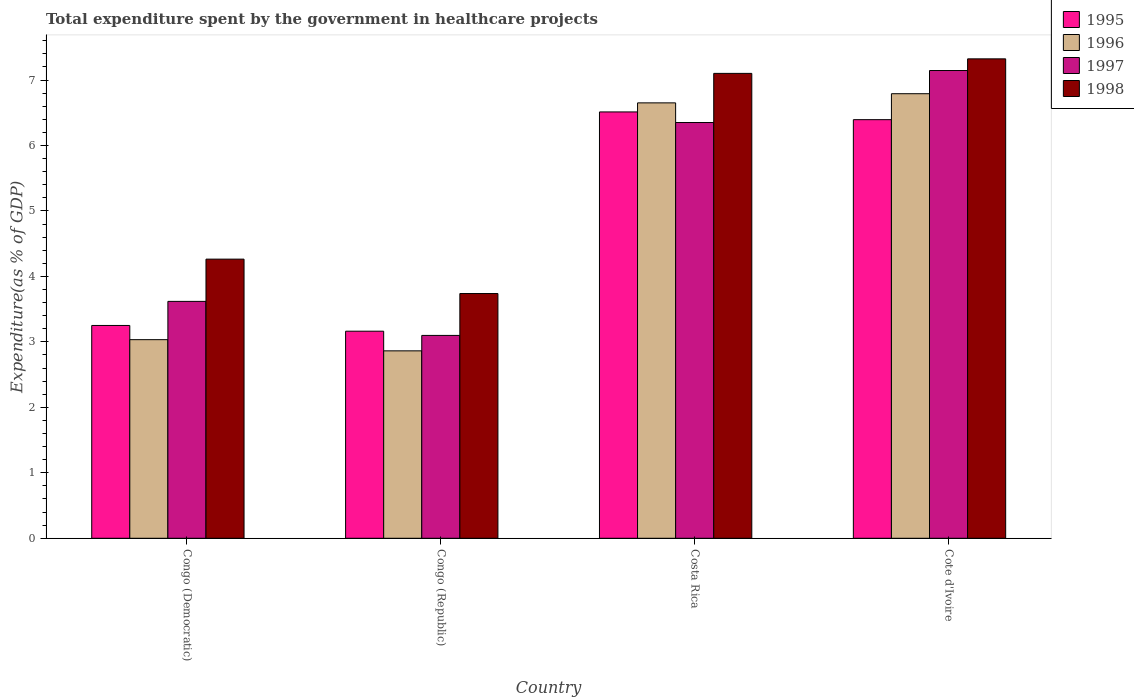How many bars are there on the 4th tick from the right?
Make the answer very short. 4. What is the label of the 1st group of bars from the left?
Your answer should be compact. Congo (Democratic). In how many cases, is the number of bars for a given country not equal to the number of legend labels?
Provide a short and direct response. 0. What is the total expenditure spent by the government in healthcare projects in 1996 in Costa Rica?
Your response must be concise. 6.65. Across all countries, what is the maximum total expenditure spent by the government in healthcare projects in 1995?
Provide a short and direct response. 6.51. Across all countries, what is the minimum total expenditure spent by the government in healthcare projects in 1998?
Your response must be concise. 3.74. In which country was the total expenditure spent by the government in healthcare projects in 1996 maximum?
Make the answer very short. Cote d'Ivoire. In which country was the total expenditure spent by the government in healthcare projects in 1998 minimum?
Your response must be concise. Congo (Republic). What is the total total expenditure spent by the government in healthcare projects in 1997 in the graph?
Give a very brief answer. 20.21. What is the difference between the total expenditure spent by the government in healthcare projects in 1995 in Congo (Republic) and that in Costa Rica?
Give a very brief answer. -3.35. What is the difference between the total expenditure spent by the government in healthcare projects in 1997 in Congo (Republic) and the total expenditure spent by the government in healthcare projects in 1996 in Costa Rica?
Your answer should be compact. -3.55. What is the average total expenditure spent by the government in healthcare projects in 1998 per country?
Offer a very short reply. 5.61. What is the difference between the total expenditure spent by the government in healthcare projects of/in 1995 and total expenditure spent by the government in healthcare projects of/in 1996 in Congo (Democratic)?
Keep it short and to the point. 0.22. What is the ratio of the total expenditure spent by the government in healthcare projects in 1996 in Congo (Republic) to that in Cote d'Ivoire?
Give a very brief answer. 0.42. Is the total expenditure spent by the government in healthcare projects in 1998 in Congo (Republic) less than that in Cote d'Ivoire?
Your answer should be very brief. Yes. Is the difference between the total expenditure spent by the government in healthcare projects in 1995 in Congo (Democratic) and Costa Rica greater than the difference between the total expenditure spent by the government in healthcare projects in 1996 in Congo (Democratic) and Costa Rica?
Ensure brevity in your answer.  Yes. What is the difference between the highest and the second highest total expenditure spent by the government in healthcare projects in 1996?
Provide a succinct answer. -3.76. What is the difference between the highest and the lowest total expenditure spent by the government in healthcare projects in 1996?
Your response must be concise. 3.93. In how many countries, is the total expenditure spent by the government in healthcare projects in 1996 greater than the average total expenditure spent by the government in healthcare projects in 1996 taken over all countries?
Your answer should be compact. 2. Is it the case that in every country, the sum of the total expenditure spent by the government in healthcare projects in 1998 and total expenditure spent by the government in healthcare projects in 1995 is greater than the sum of total expenditure spent by the government in healthcare projects in 1997 and total expenditure spent by the government in healthcare projects in 1996?
Provide a succinct answer. No. What does the 2nd bar from the left in Cote d'Ivoire represents?
Your answer should be very brief. 1996. Is it the case that in every country, the sum of the total expenditure spent by the government in healthcare projects in 1996 and total expenditure spent by the government in healthcare projects in 1995 is greater than the total expenditure spent by the government in healthcare projects in 1997?
Provide a succinct answer. Yes. How many bars are there?
Provide a short and direct response. 16. Are all the bars in the graph horizontal?
Keep it short and to the point. No. What is the difference between two consecutive major ticks on the Y-axis?
Provide a short and direct response. 1. Are the values on the major ticks of Y-axis written in scientific E-notation?
Your answer should be compact. No. Where does the legend appear in the graph?
Provide a short and direct response. Top right. How are the legend labels stacked?
Make the answer very short. Vertical. What is the title of the graph?
Provide a succinct answer. Total expenditure spent by the government in healthcare projects. What is the label or title of the X-axis?
Keep it short and to the point. Country. What is the label or title of the Y-axis?
Give a very brief answer. Expenditure(as % of GDP). What is the Expenditure(as % of GDP) of 1995 in Congo (Democratic)?
Provide a short and direct response. 3.25. What is the Expenditure(as % of GDP) of 1996 in Congo (Democratic)?
Provide a succinct answer. 3.03. What is the Expenditure(as % of GDP) of 1997 in Congo (Democratic)?
Your response must be concise. 3.62. What is the Expenditure(as % of GDP) in 1998 in Congo (Democratic)?
Your response must be concise. 4.26. What is the Expenditure(as % of GDP) of 1995 in Congo (Republic)?
Ensure brevity in your answer.  3.16. What is the Expenditure(as % of GDP) of 1996 in Congo (Republic)?
Provide a succinct answer. 2.86. What is the Expenditure(as % of GDP) in 1997 in Congo (Republic)?
Offer a terse response. 3.1. What is the Expenditure(as % of GDP) in 1998 in Congo (Republic)?
Make the answer very short. 3.74. What is the Expenditure(as % of GDP) in 1995 in Costa Rica?
Provide a succinct answer. 6.51. What is the Expenditure(as % of GDP) in 1996 in Costa Rica?
Make the answer very short. 6.65. What is the Expenditure(as % of GDP) of 1997 in Costa Rica?
Make the answer very short. 6.35. What is the Expenditure(as % of GDP) in 1998 in Costa Rica?
Ensure brevity in your answer.  7.1. What is the Expenditure(as % of GDP) of 1995 in Cote d'Ivoire?
Make the answer very short. 6.39. What is the Expenditure(as % of GDP) in 1996 in Cote d'Ivoire?
Keep it short and to the point. 6.79. What is the Expenditure(as % of GDP) in 1997 in Cote d'Ivoire?
Give a very brief answer. 7.14. What is the Expenditure(as % of GDP) in 1998 in Cote d'Ivoire?
Your response must be concise. 7.32. Across all countries, what is the maximum Expenditure(as % of GDP) in 1995?
Ensure brevity in your answer.  6.51. Across all countries, what is the maximum Expenditure(as % of GDP) in 1996?
Give a very brief answer. 6.79. Across all countries, what is the maximum Expenditure(as % of GDP) in 1997?
Your response must be concise. 7.14. Across all countries, what is the maximum Expenditure(as % of GDP) of 1998?
Offer a very short reply. 7.32. Across all countries, what is the minimum Expenditure(as % of GDP) of 1995?
Ensure brevity in your answer.  3.16. Across all countries, what is the minimum Expenditure(as % of GDP) in 1996?
Your response must be concise. 2.86. Across all countries, what is the minimum Expenditure(as % of GDP) in 1997?
Provide a succinct answer. 3.1. Across all countries, what is the minimum Expenditure(as % of GDP) in 1998?
Your answer should be very brief. 3.74. What is the total Expenditure(as % of GDP) in 1995 in the graph?
Give a very brief answer. 19.32. What is the total Expenditure(as % of GDP) of 1996 in the graph?
Provide a succinct answer. 19.34. What is the total Expenditure(as % of GDP) in 1997 in the graph?
Your response must be concise. 20.21. What is the total Expenditure(as % of GDP) of 1998 in the graph?
Offer a terse response. 22.43. What is the difference between the Expenditure(as % of GDP) in 1995 in Congo (Democratic) and that in Congo (Republic)?
Your response must be concise. 0.09. What is the difference between the Expenditure(as % of GDP) of 1996 in Congo (Democratic) and that in Congo (Republic)?
Provide a short and direct response. 0.17. What is the difference between the Expenditure(as % of GDP) of 1997 in Congo (Democratic) and that in Congo (Republic)?
Keep it short and to the point. 0.52. What is the difference between the Expenditure(as % of GDP) of 1998 in Congo (Democratic) and that in Congo (Republic)?
Keep it short and to the point. 0.53. What is the difference between the Expenditure(as % of GDP) in 1995 in Congo (Democratic) and that in Costa Rica?
Your response must be concise. -3.26. What is the difference between the Expenditure(as % of GDP) in 1996 in Congo (Democratic) and that in Costa Rica?
Provide a short and direct response. -3.62. What is the difference between the Expenditure(as % of GDP) in 1997 in Congo (Democratic) and that in Costa Rica?
Give a very brief answer. -2.73. What is the difference between the Expenditure(as % of GDP) of 1998 in Congo (Democratic) and that in Costa Rica?
Provide a short and direct response. -2.84. What is the difference between the Expenditure(as % of GDP) of 1995 in Congo (Democratic) and that in Cote d'Ivoire?
Your response must be concise. -3.14. What is the difference between the Expenditure(as % of GDP) of 1996 in Congo (Democratic) and that in Cote d'Ivoire?
Keep it short and to the point. -3.76. What is the difference between the Expenditure(as % of GDP) of 1997 in Congo (Democratic) and that in Cote d'Ivoire?
Offer a very short reply. -3.53. What is the difference between the Expenditure(as % of GDP) of 1998 in Congo (Democratic) and that in Cote d'Ivoire?
Keep it short and to the point. -3.06. What is the difference between the Expenditure(as % of GDP) in 1995 in Congo (Republic) and that in Costa Rica?
Your answer should be very brief. -3.35. What is the difference between the Expenditure(as % of GDP) of 1996 in Congo (Republic) and that in Costa Rica?
Offer a terse response. -3.79. What is the difference between the Expenditure(as % of GDP) of 1997 in Congo (Republic) and that in Costa Rica?
Provide a short and direct response. -3.25. What is the difference between the Expenditure(as % of GDP) of 1998 in Congo (Republic) and that in Costa Rica?
Provide a short and direct response. -3.36. What is the difference between the Expenditure(as % of GDP) in 1995 in Congo (Republic) and that in Cote d'Ivoire?
Your response must be concise. -3.23. What is the difference between the Expenditure(as % of GDP) of 1996 in Congo (Republic) and that in Cote d'Ivoire?
Offer a very short reply. -3.93. What is the difference between the Expenditure(as % of GDP) in 1997 in Congo (Republic) and that in Cote d'Ivoire?
Keep it short and to the point. -4.05. What is the difference between the Expenditure(as % of GDP) in 1998 in Congo (Republic) and that in Cote d'Ivoire?
Your answer should be very brief. -3.58. What is the difference between the Expenditure(as % of GDP) of 1995 in Costa Rica and that in Cote d'Ivoire?
Offer a terse response. 0.12. What is the difference between the Expenditure(as % of GDP) in 1996 in Costa Rica and that in Cote d'Ivoire?
Your answer should be compact. -0.14. What is the difference between the Expenditure(as % of GDP) of 1997 in Costa Rica and that in Cote d'Ivoire?
Provide a succinct answer. -0.79. What is the difference between the Expenditure(as % of GDP) of 1998 in Costa Rica and that in Cote d'Ivoire?
Offer a terse response. -0.22. What is the difference between the Expenditure(as % of GDP) in 1995 in Congo (Democratic) and the Expenditure(as % of GDP) in 1996 in Congo (Republic)?
Your answer should be compact. 0.39. What is the difference between the Expenditure(as % of GDP) of 1995 in Congo (Democratic) and the Expenditure(as % of GDP) of 1997 in Congo (Republic)?
Offer a terse response. 0.15. What is the difference between the Expenditure(as % of GDP) in 1995 in Congo (Democratic) and the Expenditure(as % of GDP) in 1998 in Congo (Republic)?
Provide a short and direct response. -0.49. What is the difference between the Expenditure(as % of GDP) in 1996 in Congo (Democratic) and the Expenditure(as % of GDP) in 1997 in Congo (Republic)?
Make the answer very short. -0.06. What is the difference between the Expenditure(as % of GDP) in 1996 in Congo (Democratic) and the Expenditure(as % of GDP) in 1998 in Congo (Republic)?
Offer a terse response. -0.7. What is the difference between the Expenditure(as % of GDP) in 1997 in Congo (Democratic) and the Expenditure(as % of GDP) in 1998 in Congo (Republic)?
Give a very brief answer. -0.12. What is the difference between the Expenditure(as % of GDP) of 1995 in Congo (Democratic) and the Expenditure(as % of GDP) of 1996 in Costa Rica?
Your answer should be very brief. -3.4. What is the difference between the Expenditure(as % of GDP) in 1995 in Congo (Democratic) and the Expenditure(as % of GDP) in 1997 in Costa Rica?
Make the answer very short. -3.1. What is the difference between the Expenditure(as % of GDP) of 1995 in Congo (Democratic) and the Expenditure(as % of GDP) of 1998 in Costa Rica?
Give a very brief answer. -3.85. What is the difference between the Expenditure(as % of GDP) of 1996 in Congo (Democratic) and the Expenditure(as % of GDP) of 1997 in Costa Rica?
Give a very brief answer. -3.32. What is the difference between the Expenditure(as % of GDP) in 1996 in Congo (Democratic) and the Expenditure(as % of GDP) in 1998 in Costa Rica?
Keep it short and to the point. -4.07. What is the difference between the Expenditure(as % of GDP) in 1997 in Congo (Democratic) and the Expenditure(as % of GDP) in 1998 in Costa Rica?
Your answer should be very brief. -3.48. What is the difference between the Expenditure(as % of GDP) in 1995 in Congo (Democratic) and the Expenditure(as % of GDP) in 1996 in Cote d'Ivoire?
Make the answer very short. -3.54. What is the difference between the Expenditure(as % of GDP) of 1995 in Congo (Democratic) and the Expenditure(as % of GDP) of 1997 in Cote d'Ivoire?
Give a very brief answer. -3.89. What is the difference between the Expenditure(as % of GDP) of 1995 in Congo (Democratic) and the Expenditure(as % of GDP) of 1998 in Cote d'Ivoire?
Keep it short and to the point. -4.07. What is the difference between the Expenditure(as % of GDP) in 1996 in Congo (Democratic) and the Expenditure(as % of GDP) in 1997 in Cote d'Ivoire?
Provide a succinct answer. -4.11. What is the difference between the Expenditure(as % of GDP) of 1996 in Congo (Democratic) and the Expenditure(as % of GDP) of 1998 in Cote d'Ivoire?
Offer a very short reply. -4.29. What is the difference between the Expenditure(as % of GDP) of 1997 in Congo (Democratic) and the Expenditure(as % of GDP) of 1998 in Cote d'Ivoire?
Provide a succinct answer. -3.7. What is the difference between the Expenditure(as % of GDP) of 1995 in Congo (Republic) and the Expenditure(as % of GDP) of 1996 in Costa Rica?
Ensure brevity in your answer.  -3.49. What is the difference between the Expenditure(as % of GDP) in 1995 in Congo (Republic) and the Expenditure(as % of GDP) in 1997 in Costa Rica?
Your answer should be compact. -3.19. What is the difference between the Expenditure(as % of GDP) in 1995 in Congo (Republic) and the Expenditure(as % of GDP) in 1998 in Costa Rica?
Ensure brevity in your answer.  -3.94. What is the difference between the Expenditure(as % of GDP) of 1996 in Congo (Republic) and the Expenditure(as % of GDP) of 1997 in Costa Rica?
Offer a terse response. -3.49. What is the difference between the Expenditure(as % of GDP) in 1996 in Congo (Republic) and the Expenditure(as % of GDP) in 1998 in Costa Rica?
Offer a very short reply. -4.24. What is the difference between the Expenditure(as % of GDP) in 1997 in Congo (Republic) and the Expenditure(as % of GDP) in 1998 in Costa Rica?
Give a very brief answer. -4. What is the difference between the Expenditure(as % of GDP) of 1995 in Congo (Republic) and the Expenditure(as % of GDP) of 1996 in Cote d'Ivoire?
Provide a succinct answer. -3.63. What is the difference between the Expenditure(as % of GDP) of 1995 in Congo (Republic) and the Expenditure(as % of GDP) of 1997 in Cote d'Ivoire?
Ensure brevity in your answer.  -3.98. What is the difference between the Expenditure(as % of GDP) of 1995 in Congo (Republic) and the Expenditure(as % of GDP) of 1998 in Cote d'Ivoire?
Ensure brevity in your answer.  -4.16. What is the difference between the Expenditure(as % of GDP) in 1996 in Congo (Republic) and the Expenditure(as % of GDP) in 1997 in Cote d'Ivoire?
Offer a very short reply. -4.28. What is the difference between the Expenditure(as % of GDP) of 1996 in Congo (Republic) and the Expenditure(as % of GDP) of 1998 in Cote d'Ivoire?
Your answer should be very brief. -4.46. What is the difference between the Expenditure(as % of GDP) in 1997 in Congo (Republic) and the Expenditure(as % of GDP) in 1998 in Cote d'Ivoire?
Provide a succinct answer. -4.22. What is the difference between the Expenditure(as % of GDP) of 1995 in Costa Rica and the Expenditure(as % of GDP) of 1996 in Cote d'Ivoire?
Make the answer very short. -0.28. What is the difference between the Expenditure(as % of GDP) of 1995 in Costa Rica and the Expenditure(as % of GDP) of 1997 in Cote d'Ivoire?
Provide a short and direct response. -0.63. What is the difference between the Expenditure(as % of GDP) of 1995 in Costa Rica and the Expenditure(as % of GDP) of 1998 in Cote d'Ivoire?
Your response must be concise. -0.81. What is the difference between the Expenditure(as % of GDP) of 1996 in Costa Rica and the Expenditure(as % of GDP) of 1997 in Cote d'Ivoire?
Provide a short and direct response. -0.49. What is the difference between the Expenditure(as % of GDP) in 1996 in Costa Rica and the Expenditure(as % of GDP) in 1998 in Cote d'Ivoire?
Provide a short and direct response. -0.67. What is the difference between the Expenditure(as % of GDP) of 1997 in Costa Rica and the Expenditure(as % of GDP) of 1998 in Cote d'Ivoire?
Offer a terse response. -0.97. What is the average Expenditure(as % of GDP) of 1995 per country?
Your answer should be compact. 4.83. What is the average Expenditure(as % of GDP) in 1996 per country?
Make the answer very short. 4.83. What is the average Expenditure(as % of GDP) in 1997 per country?
Provide a short and direct response. 5.05. What is the average Expenditure(as % of GDP) of 1998 per country?
Provide a short and direct response. 5.61. What is the difference between the Expenditure(as % of GDP) of 1995 and Expenditure(as % of GDP) of 1996 in Congo (Democratic)?
Offer a terse response. 0.22. What is the difference between the Expenditure(as % of GDP) in 1995 and Expenditure(as % of GDP) in 1997 in Congo (Democratic)?
Ensure brevity in your answer.  -0.37. What is the difference between the Expenditure(as % of GDP) of 1995 and Expenditure(as % of GDP) of 1998 in Congo (Democratic)?
Keep it short and to the point. -1.01. What is the difference between the Expenditure(as % of GDP) in 1996 and Expenditure(as % of GDP) in 1997 in Congo (Democratic)?
Provide a short and direct response. -0.58. What is the difference between the Expenditure(as % of GDP) in 1996 and Expenditure(as % of GDP) in 1998 in Congo (Democratic)?
Ensure brevity in your answer.  -1.23. What is the difference between the Expenditure(as % of GDP) of 1997 and Expenditure(as % of GDP) of 1998 in Congo (Democratic)?
Ensure brevity in your answer.  -0.65. What is the difference between the Expenditure(as % of GDP) in 1995 and Expenditure(as % of GDP) in 1996 in Congo (Republic)?
Offer a terse response. 0.3. What is the difference between the Expenditure(as % of GDP) of 1995 and Expenditure(as % of GDP) of 1997 in Congo (Republic)?
Your response must be concise. 0.06. What is the difference between the Expenditure(as % of GDP) of 1995 and Expenditure(as % of GDP) of 1998 in Congo (Republic)?
Provide a short and direct response. -0.58. What is the difference between the Expenditure(as % of GDP) in 1996 and Expenditure(as % of GDP) in 1997 in Congo (Republic)?
Make the answer very short. -0.24. What is the difference between the Expenditure(as % of GDP) in 1996 and Expenditure(as % of GDP) in 1998 in Congo (Republic)?
Offer a terse response. -0.88. What is the difference between the Expenditure(as % of GDP) in 1997 and Expenditure(as % of GDP) in 1998 in Congo (Republic)?
Keep it short and to the point. -0.64. What is the difference between the Expenditure(as % of GDP) of 1995 and Expenditure(as % of GDP) of 1996 in Costa Rica?
Provide a succinct answer. -0.14. What is the difference between the Expenditure(as % of GDP) of 1995 and Expenditure(as % of GDP) of 1997 in Costa Rica?
Provide a short and direct response. 0.16. What is the difference between the Expenditure(as % of GDP) of 1995 and Expenditure(as % of GDP) of 1998 in Costa Rica?
Ensure brevity in your answer.  -0.59. What is the difference between the Expenditure(as % of GDP) in 1996 and Expenditure(as % of GDP) in 1997 in Costa Rica?
Make the answer very short. 0.3. What is the difference between the Expenditure(as % of GDP) of 1996 and Expenditure(as % of GDP) of 1998 in Costa Rica?
Offer a terse response. -0.45. What is the difference between the Expenditure(as % of GDP) in 1997 and Expenditure(as % of GDP) in 1998 in Costa Rica?
Ensure brevity in your answer.  -0.75. What is the difference between the Expenditure(as % of GDP) in 1995 and Expenditure(as % of GDP) in 1996 in Cote d'Ivoire?
Your answer should be very brief. -0.4. What is the difference between the Expenditure(as % of GDP) in 1995 and Expenditure(as % of GDP) in 1997 in Cote d'Ivoire?
Provide a succinct answer. -0.75. What is the difference between the Expenditure(as % of GDP) in 1995 and Expenditure(as % of GDP) in 1998 in Cote d'Ivoire?
Make the answer very short. -0.93. What is the difference between the Expenditure(as % of GDP) of 1996 and Expenditure(as % of GDP) of 1997 in Cote d'Ivoire?
Provide a succinct answer. -0.35. What is the difference between the Expenditure(as % of GDP) of 1996 and Expenditure(as % of GDP) of 1998 in Cote d'Ivoire?
Give a very brief answer. -0.53. What is the difference between the Expenditure(as % of GDP) of 1997 and Expenditure(as % of GDP) of 1998 in Cote d'Ivoire?
Your answer should be very brief. -0.18. What is the ratio of the Expenditure(as % of GDP) of 1995 in Congo (Democratic) to that in Congo (Republic)?
Provide a succinct answer. 1.03. What is the ratio of the Expenditure(as % of GDP) in 1996 in Congo (Democratic) to that in Congo (Republic)?
Give a very brief answer. 1.06. What is the ratio of the Expenditure(as % of GDP) in 1997 in Congo (Democratic) to that in Congo (Republic)?
Provide a succinct answer. 1.17. What is the ratio of the Expenditure(as % of GDP) of 1998 in Congo (Democratic) to that in Congo (Republic)?
Offer a very short reply. 1.14. What is the ratio of the Expenditure(as % of GDP) in 1995 in Congo (Democratic) to that in Costa Rica?
Ensure brevity in your answer.  0.5. What is the ratio of the Expenditure(as % of GDP) in 1996 in Congo (Democratic) to that in Costa Rica?
Make the answer very short. 0.46. What is the ratio of the Expenditure(as % of GDP) of 1997 in Congo (Democratic) to that in Costa Rica?
Ensure brevity in your answer.  0.57. What is the ratio of the Expenditure(as % of GDP) of 1998 in Congo (Democratic) to that in Costa Rica?
Make the answer very short. 0.6. What is the ratio of the Expenditure(as % of GDP) of 1995 in Congo (Democratic) to that in Cote d'Ivoire?
Make the answer very short. 0.51. What is the ratio of the Expenditure(as % of GDP) of 1996 in Congo (Democratic) to that in Cote d'Ivoire?
Offer a terse response. 0.45. What is the ratio of the Expenditure(as % of GDP) of 1997 in Congo (Democratic) to that in Cote d'Ivoire?
Make the answer very short. 0.51. What is the ratio of the Expenditure(as % of GDP) in 1998 in Congo (Democratic) to that in Cote d'Ivoire?
Offer a very short reply. 0.58. What is the ratio of the Expenditure(as % of GDP) of 1995 in Congo (Republic) to that in Costa Rica?
Offer a very short reply. 0.49. What is the ratio of the Expenditure(as % of GDP) in 1996 in Congo (Republic) to that in Costa Rica?
Offer a terse response. 0.43. What is the ratio of the Expenditure(as % of GDP) in 1997 in Congo (Republic) to that in Costa Rica?
Your answer should be compact. 0.49. What is the ratio of the Expenditure(as % of GDP) of 1998 in Congo (Republic) to that in Costa Rica?
Make the answer very short. 0.53. What is the ratio of the Expenditure(as % of GDP) in 1995 in Congo (Republic) to that in Cote d'Ivoire?
Ensure brevity in your answer.  0.49. What is the ratio of the Expenditure(as % of GDP) in 1996 in Congo (Republic) to that in Cote d'Ivoire?
Make the answer very short. 0.42. What is the ratio of the Expenditure(as % of GDP) in 1997 in Congo (Republic) to that in Cote d'Ivoire?
Your answer should be very brief. 0.43. What is the ratio of the Expenditure(as % of GDP) of 1998 in Congo (Republic) to that in Cote d'Ivoire?
Offer a very short reply. 0.51. What is the ratio of the Expenditure(as % of GDP) in 1995 in Costa Rica to that in Cote d'Ivoire?
Keep it short and to the point. 1.02. What is the ratio of the Expenditure(as % of GDP) of 1996 in Costa Rica to that in Cote d'Ivoire?
Offer a terse response. 0.98. What is the ratio of the Expenditure(as % of GDP) in 1997 in Costa Rica to that in Cote d'Ivoire?
Offer a very short reply. 0.89. What is the ratio of the Expenditure(as % of GDP) in 1998 in Costa Rica to that in Cote d'Ivoire?
Ensure brevity in your answer.  0.97. What is the difference between the highest and the second highest Expenditure(as % of GDP) in 1995?
Ensure brevity in your answer.  0.12. What is the difference between the highest and the second highest Expenditure(as % of GDP) in 1996?
Your response must be concise. 0.14. What is the difference between the highest and the second highest Expenditure(as % of GDP) in 1997?
Ensure brevity in your answer.  0.79. What is the difference between the highest and the second highest Expenditure(as % of GDP) of 1998?
Offer a terse response. 0.22. What is the difference between the highest and the lowest Expenditure(as % of GDP) in 1995?
Make the answer very short. 3.35. What is the difference between the highest and the lowest Expenditure(as % of GDP) of 1996?
Your answer should be compact. 3.93. What is the difference between the highest and the lowest Expenditure(as % of GDP) of 1997?
Provide a succinct answer. 4.05. What is the difference between the highest and the lowest Expenditure(as % of GDP) of 1998?
Provide a short and direct response. 3.58. 